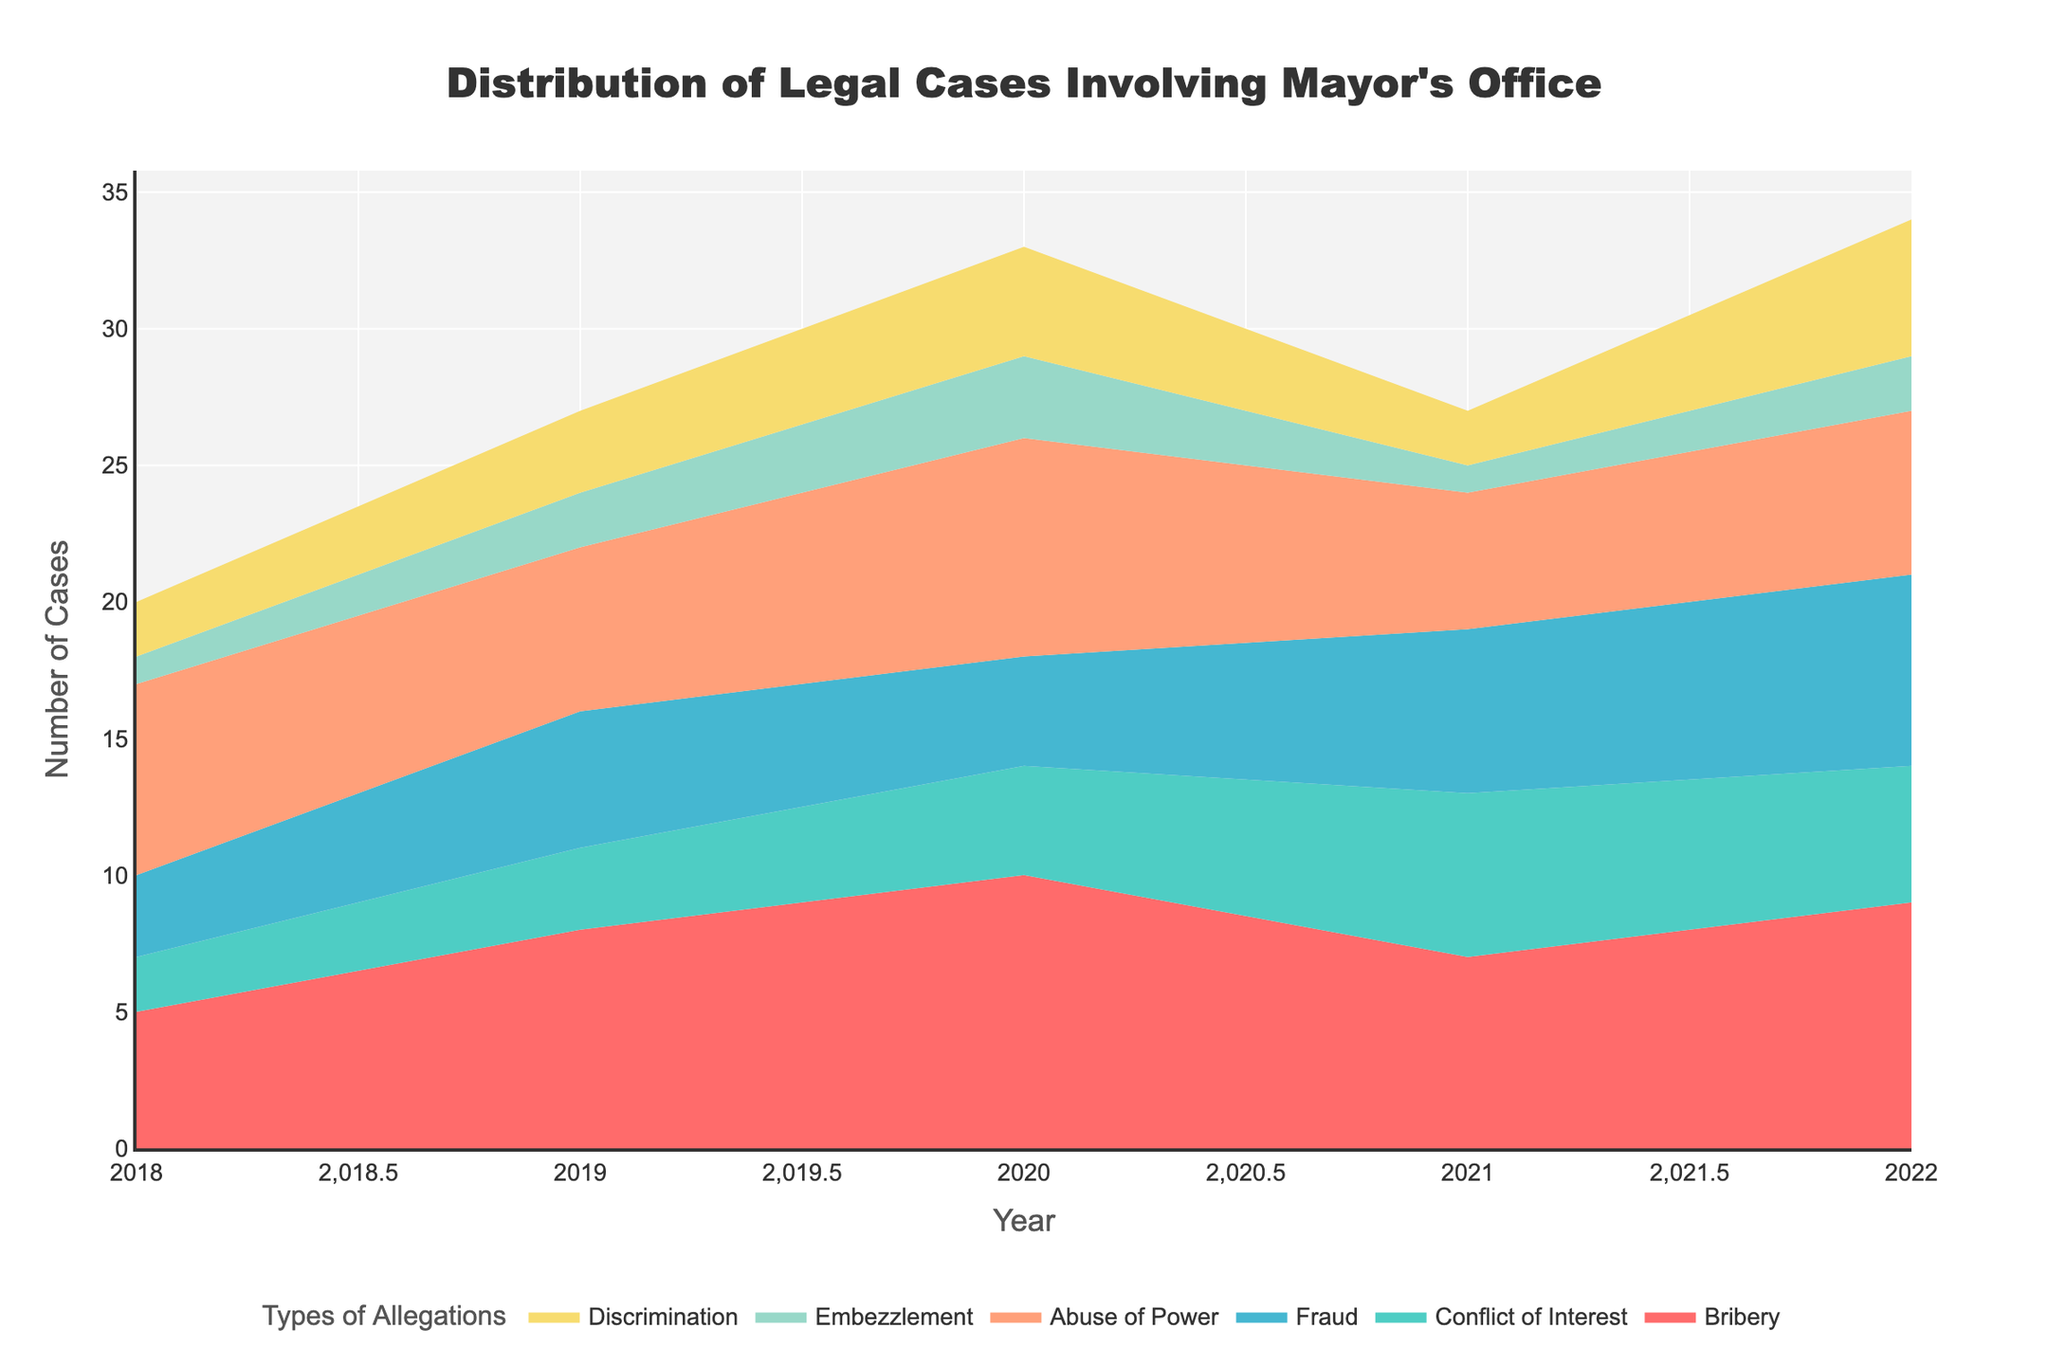What's the title of the figure? The title of the figure is at the top of the chart, written in a larger, bold font for emphasis.
Answer: Distribution of Legal Cases Involving Mayor's Office Which year had the highest number of legal cases under "Bribery"? By reviewing the area corresponding to "Bribery," the highest peak occurs in the year 2020.
Answer: 2020 How many categories of allegations are tracked in the figure? The legend at the bottom of the figure lists all the types of allegations, which are color-coded.
Answer: 6 What is the trend for "Conflict of Interest" cases from 2018 to 2022? Observing the line that represents "Conflict of Interest," we can see an initial increase from 2018 to 2021, followed by a slight decrease in 2022.
Answer: Increase, then Decrease Which type of allegation has the least number of cases consistently? By examining the height of the areas throughout the years, "Embezzlement" consistently shows the smallest area, indicating the least number of cases.
Answer: Embezzlement In which year did the "Discrimination" cases peak? Check the highest value within the "Discrimination" area slice across different years; the peak height is in 2022.
Answer: 2022 What is the total number of legal cases in 2019? Sum the values for all types of allegations in 2019: 8 (Bribery) + 3 (Conflict of Interest) + 5 (Fraud) + 6 (Abuse of Power) + 2 (Embezzlement) + 3 (Discrimination) = 27.
Answer: 27 Which type of allegation shows consistent increase over the years? Following the ascending patterns across years, "Discrimination" consistently increases from 2018 to 2022.
Answer: Discrimination How do "Bribery" cases in 2021 compare to those in 2020? Comparing the "Bribery" area between the two years, 2021 has 7 cases while 2020 has 10 cases. So, 2021 shows fewer cases.
Answer: 2021 < 2020 What is the combined total number of "Fraud" cases for the years 2018 and 2022? Add the values of "Fraud" cases for these two years: 3 (2018) + 7 (2022) = 10.
Answer: 10 